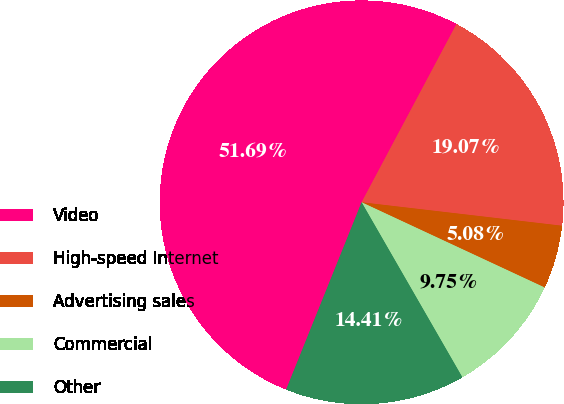Convert chart. <chart><loc_0><loc_0><loc_500><loc_500><pie_chart><fcel>Video<fcel>High-speed Internet<fcel>Advertising sales<fcel>Commercial<fcel>Other<nl><fcel>51.69%<fcel>19.07%<fcel>5.08%<fcel>9.75%<fcel>14.41%<nl></chart> 